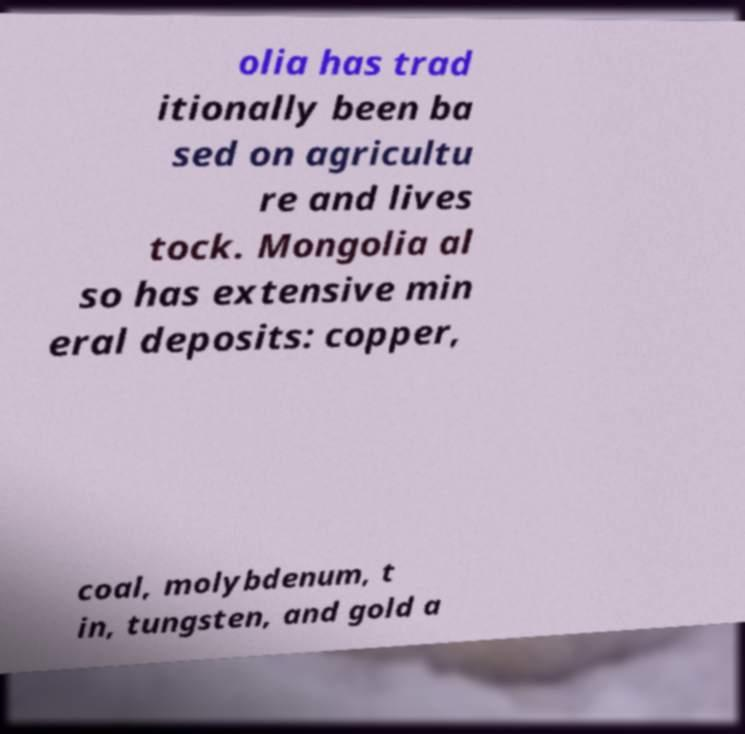Could you extract and type out the text from this image? olia has trad itionally been ba sed on agricultu re and lives tock. Mongolia al so has extensive min eral deposits: copper, coal, molybdenum, t in, tungsten, and gold a 